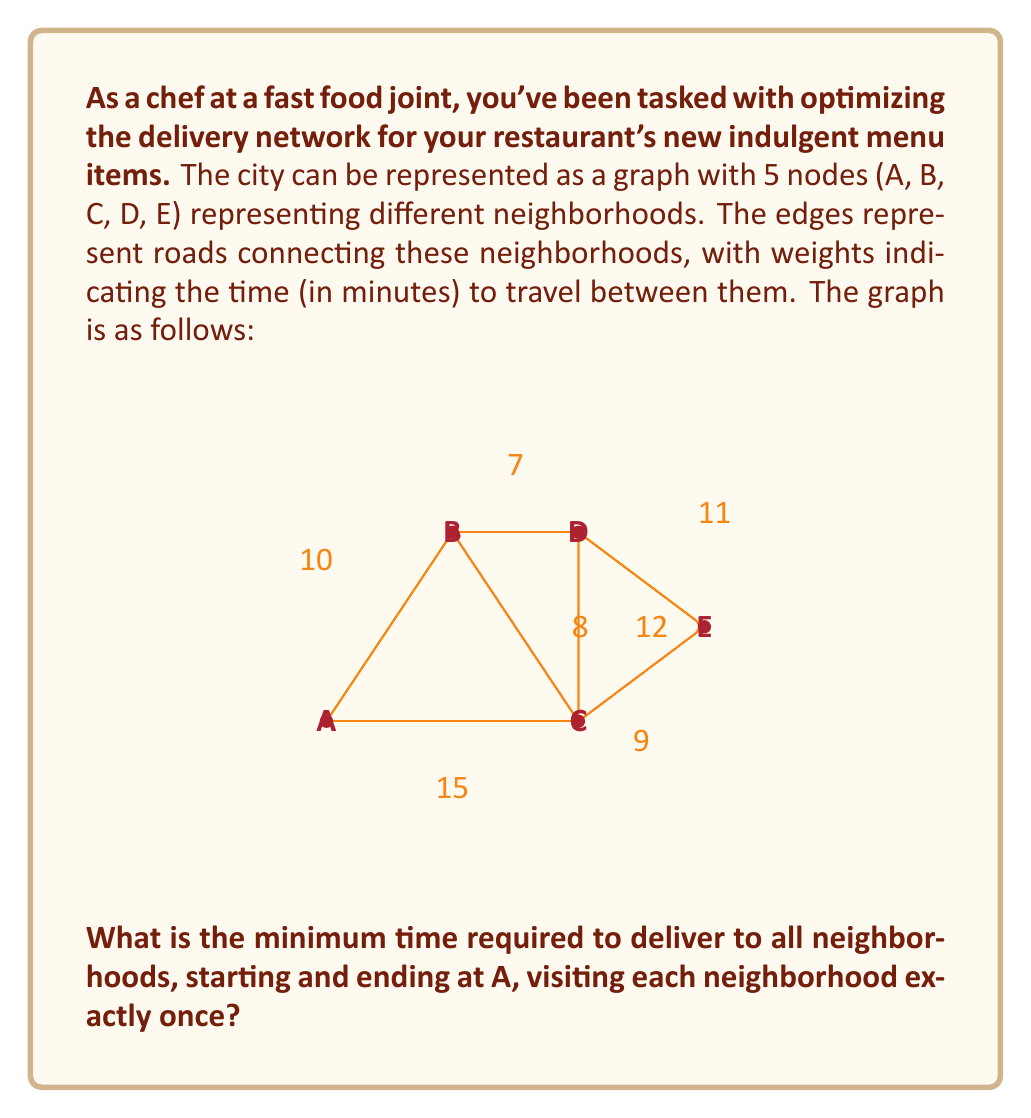Can you solve this math problem? To solve this problem, we need to find the Hamiltonian cycle with the minimum total weight in the given graph. This is known as the Traveling Salesman Problem (TSP).

For a small graph like this, we can solve it by enumerating all possible cycles and choosing the one with the minimum total weight. The possible cycles starting and ending at A are:

1. A-B-C-D-E-A
2. A-B-C-E-D-A
3. A-B-D-C-E-A
4. A-B-D-E-C-A
5. A-C-B-D-E-A
6. A-C-D-B-E-A
7. A-C-E-B-D-A
8. A-C-E-D-B-A

Let's calculate the total weight for each cycle:

1. A-B-C-D-E-A: $10 + 8 + 12 + 11 + 15 = 56$
2. A-B-C-E-D-A: $10 + 8 + 9 + 11 + 15 = 53$
3. A-B-D-C-E-A: $10 + 7 + 12 + 9 + 15 = 53$
4. A-B-D-E-C-A: $10 + 7 + 11 + 9 + 15 = 52$
5. A-C-B-D-E-A: $15 + 8 + 7 + 11 + 15 = 56$
6. A-C-D-B-E-A: $15 + 12 + 7 + 11 + 15 = 60$
7. A-C-E-B-D-A: $15 + 9 + 11 + 7 + 15 = 57$
8. A-C-E-D-B-A: $15 + 9 + 11 + 7 + 10 = 52$

The minimum total weight among these cycles is 52 minutes, which can be achieved by two different routes: A-B-D-E-C-A and A-C-E-D-B-A.
Answer: The minimum time required to deliver to all neighborhoods, starting and ending at A, visiting each neighborhood exactly once is 52 minutes. 